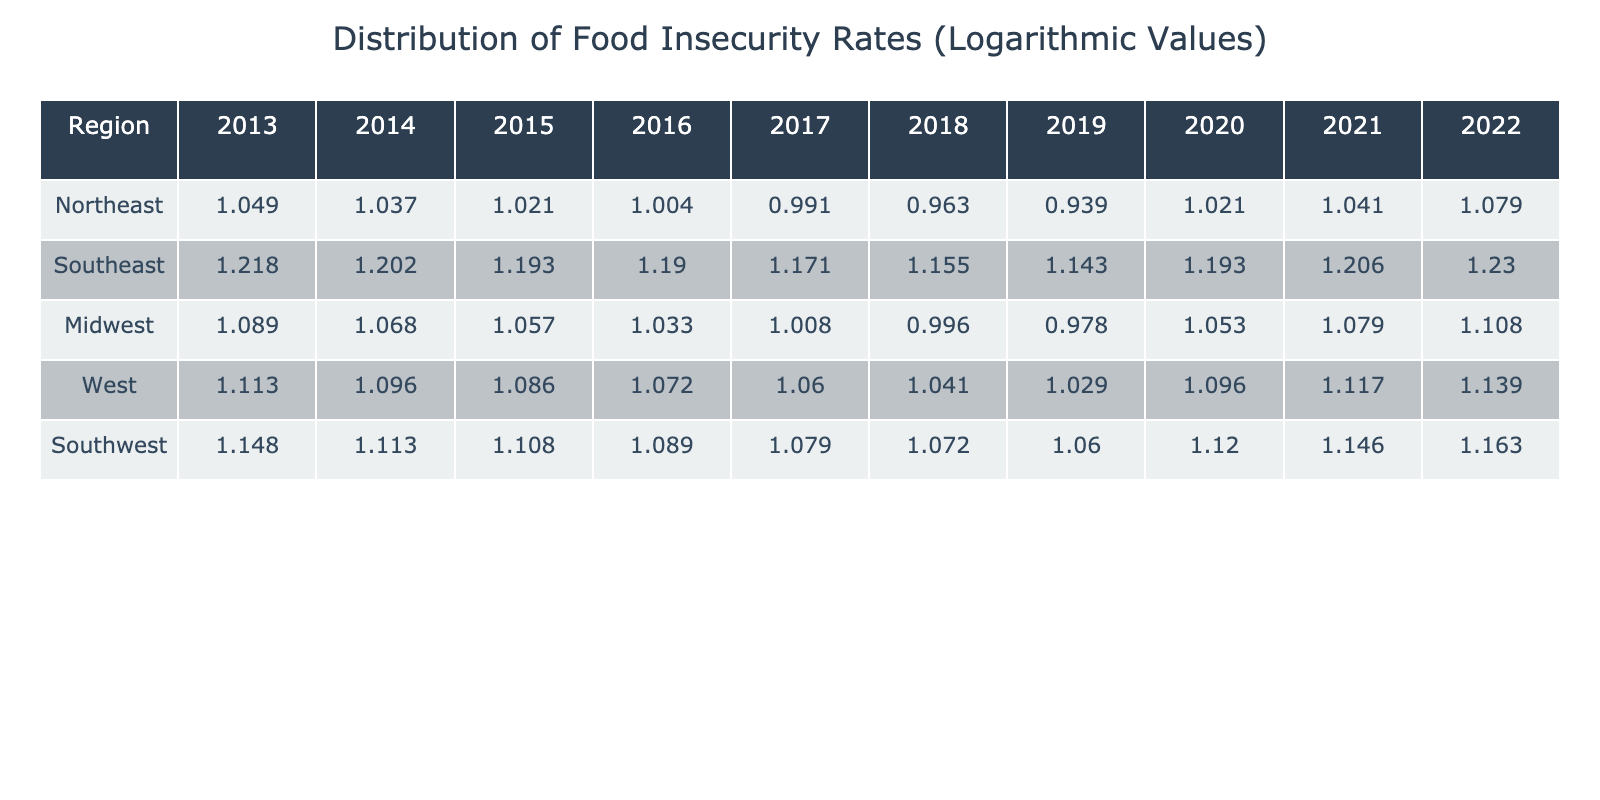What was the food insecurity rate in the Northeast in 2019? The table shows that in 2019, the food insecurity rate in the Northeast was 8.7%.
Answer: 8.7 Which region had the highest food insecurity rate in 2022? In 2022, the Southeast had the highest food insecurity rate at 17.0%.
Answer: 17.0 What is the average food insecurity rate in the Midwest over the years provided? Calculating the average: (12.3 + 11.7 + 11.4 + 10.8 + 10.2 + 9.9 + 9.5 + 11.3 + 12.0 + 12.8)/10 = 11.29%
Answer: 11.29 Did food insecurity rates in the Northeast decrease from 2013 to 2018? Yes, the food insecurity rates in the Northeast decreased from 11.2% in 2013 to 9.2% in 2018.
Answer: Yes What was the change in food insecurity rate for the Southeast from 2013 to 2022? The rate in 2013 was 16.5% and in 2022 it was 17.0%. The change is 17.0 - 16.5 = 0.5%, which is an increase.
Answer: 0.5% increase What was the lowest food insecurity rate recorded in the Southwest during the decade? The lowest rate recorded in the Southwest was 11.5% in 2019.
Answer: 11.5 How many regions experienced an increase in food insecurity rates from 2021 to 2022? Analyzing 2021 and 2022: Northeast (11.0 to 12.0), Southeast (16.1 to 17.0), Midwest (12.0 to 12.8), West (13.1 to 13.8), and Southwest (14.0 to 14.5) all show increases. This indicates that all five regions experienced an increase.
Answer: 5 regions Is the food insecurity rate in the West for 2021 higher than the national average of 12%? Yes, the rate in the West for 2021 was 13.1%, which is higher than the national average of 12%.
Answer: Yes How does the food insecurity rate in the Northeast in 2020 compare to its rate in 2016? The rate in 2020 (10.5%) was higher than in 2016 (10.1%), marking an increase of 0.4%.
Answer: Increase of 0.4% 